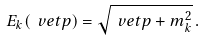Convert formula to latex. <formula><loc_0><loc_0><loc_500><loc_500>E _ { k } ( \ v e t { p } ) = \sqrt { \ v e t { p } + m _ { k } ^ { 2 } } \, .</formula> 